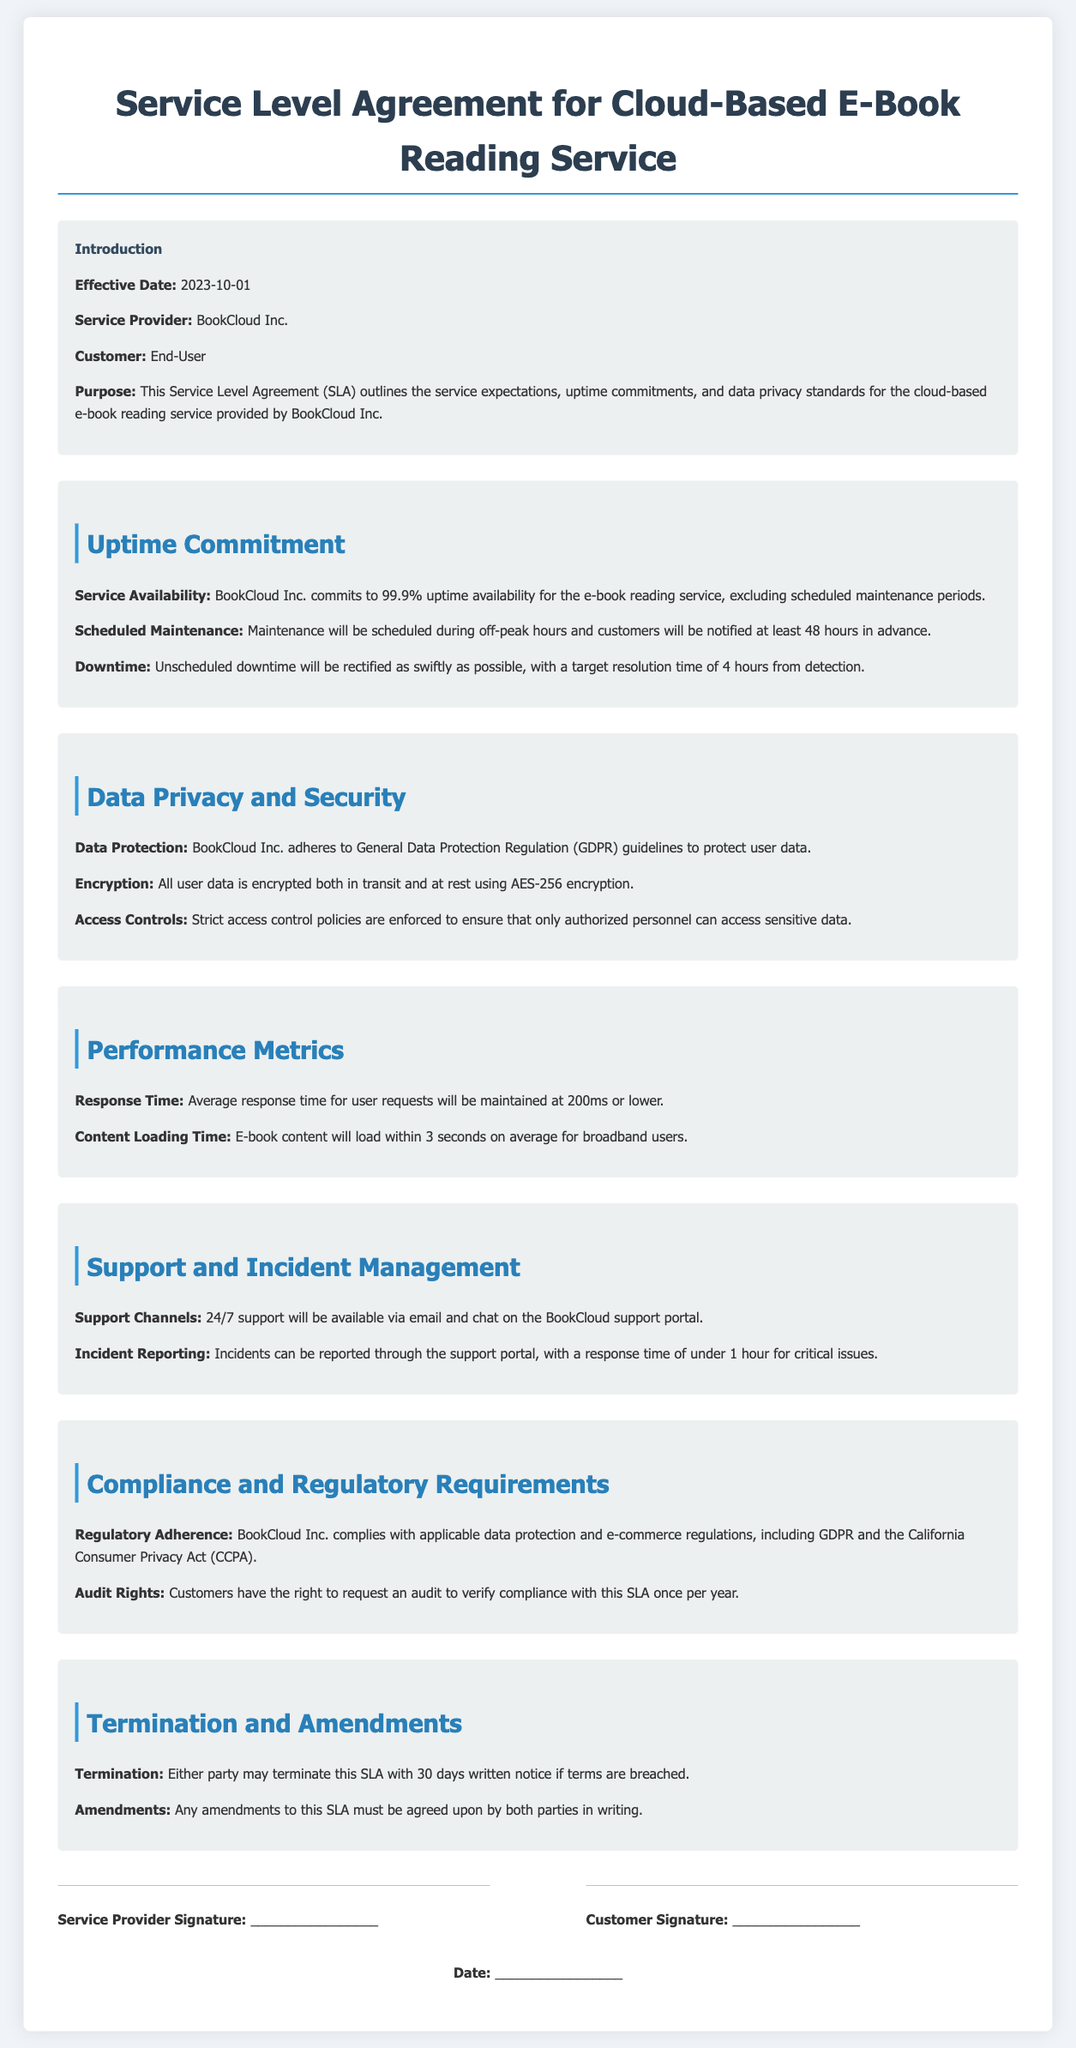What is the effective date of the SLA? The effective date is stated in the introduction section of the document.
Answer: 2023-10-01 What is the uptime commitment percentage? The uptime commitment percentage can be found in the Uptime Commitment section.
Answer: 99.9% How long before scheduled maintenance will customers be notified? The notification period for scheduled maintenance is mentioned under Scheduled Maintenance.
Answer: 48 hours What encryption standard is used for user data? The encryption standard is specified in the Data Privacy and Security section.
Answer: AES-256 What is the average response time for user requests? The average response time is described in the Performance Metrics section.
Answer: 200ms What is the target resolution time for unscheduled downtime? The target resolution time is noted in the Uptime Commitment section.
Answer: 4 hours How many audits can customers request per year? The number of audits allowed per year is explained in the Compliance and Regulatory Requirements section.
Answer: once What is the notice period to terminate the SLA? The notice period for termination is found in the Termination and Amendments section.
Answer: 30 days What channels are available for support? The support channels available are mentioned under Support and Incident Management.
Answer: email and chat 